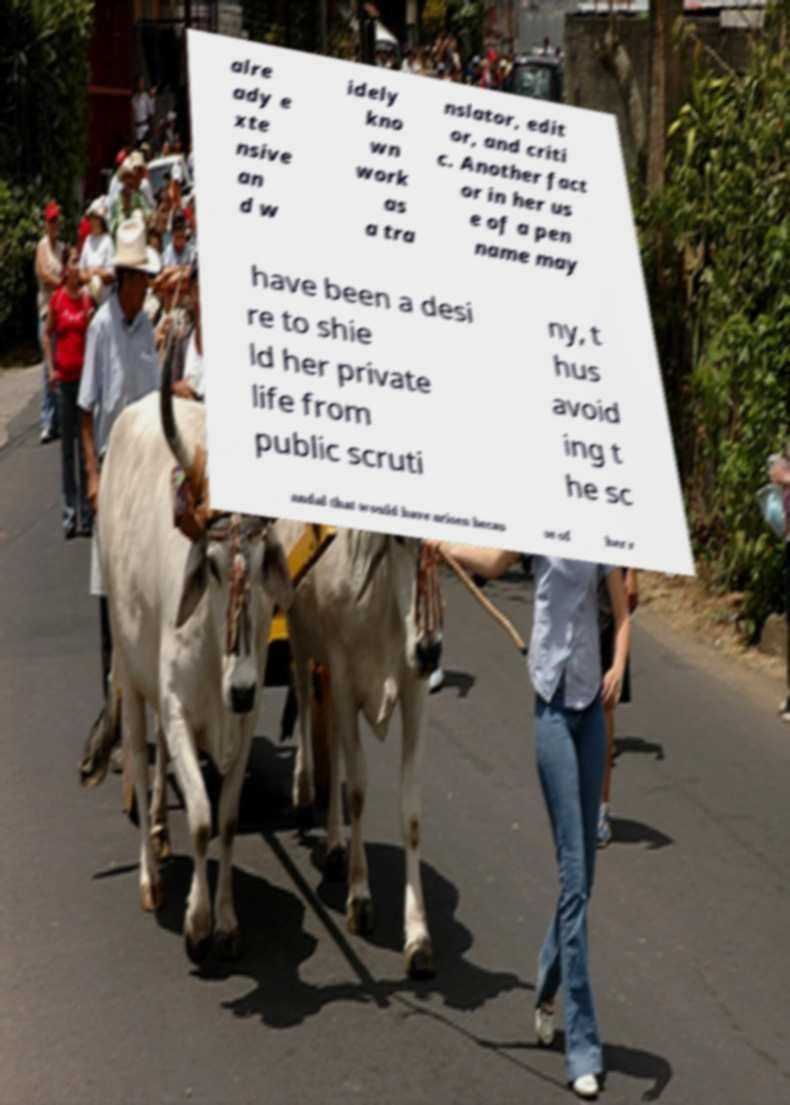Could you extract and type out the text from this image? alre ady e xte nsive an d w idely kno wn work as a tra nslator, edit or, and criti c. Another fact or in her us e of a pen name may have been a desi re to shie ld her private life from public scruti ny, t hus avoid ing t he sc andal that would have arisen becau se of her r 